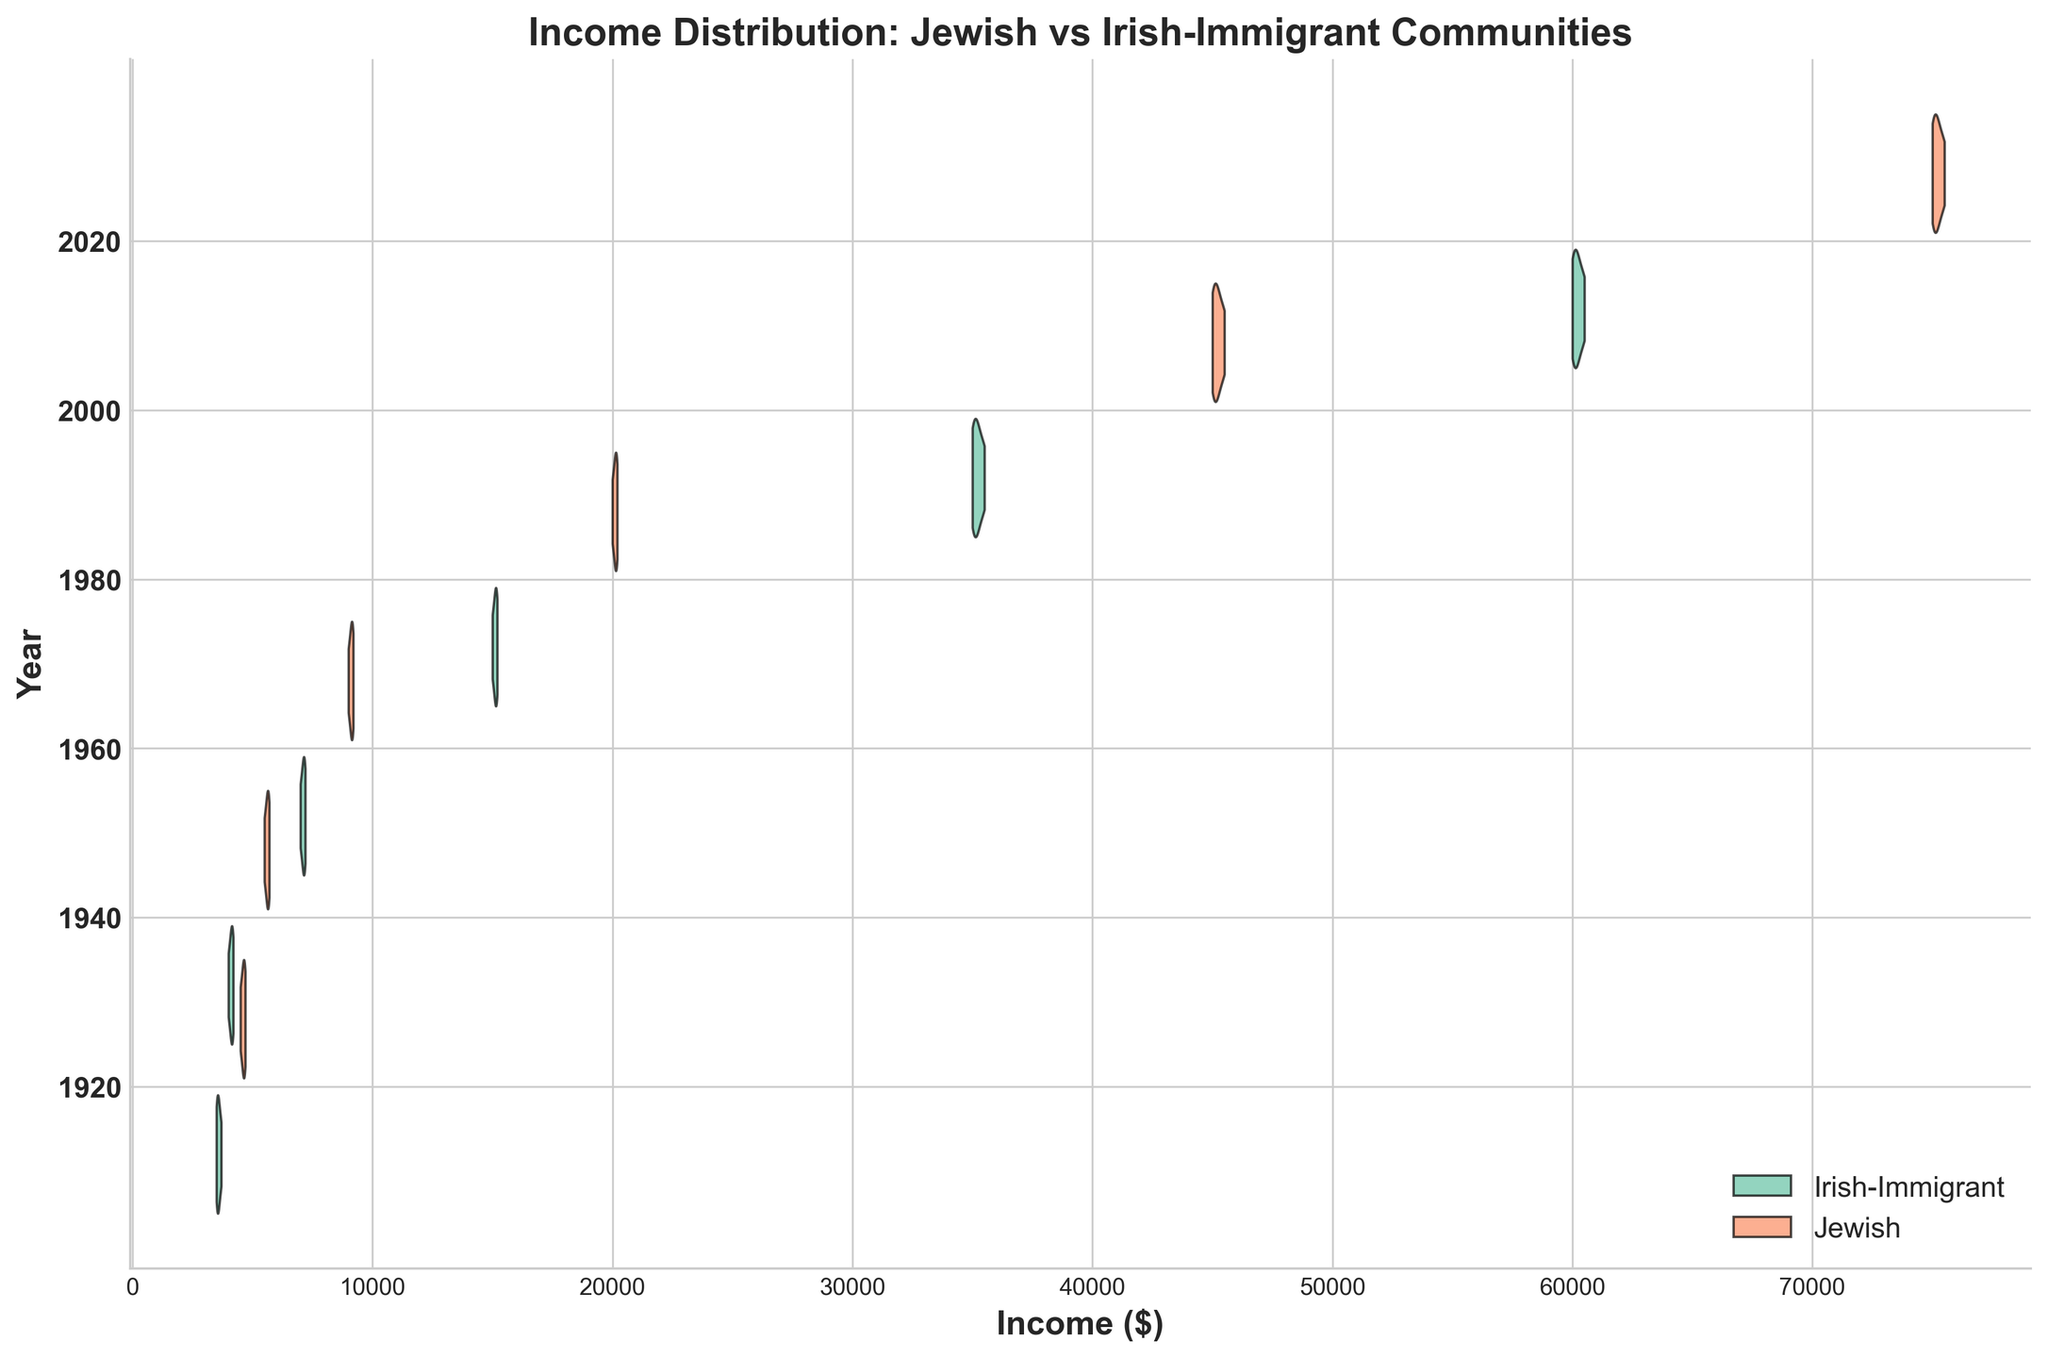What is the title of the figure? The title is located at the top of the figure. It provides a summary of the data being represented.
Answer: Income Distribution: Jewish vs Irish-Immigrant Communities What do the y-axis labels signify? The y-axis labels correspond to different years, indicating the time periods for which the income distributions are shown.
Answer: Years How are the two communities distinguished in the chart? The two communities are distinguished by different colors as indicated in the legend at the lower right of the chart.
Answer: By different colors Which community had a higher income distribution in 1940? By comparing the positions of the violin plots for 1940, the Jewish community's plot is centered around higher income values compared to the Irish-Immigrant community.
Answer: Jewish community How have the median incomes for both communities changed from 1920 to 2020? The median incomes can be estimated from the horizontal center of each violin plot at the respective years. Both communities show an upward trend from 1920 to 2020, with Jewish incomes consistently higher than Irish-Immigrant incomes.
Answer: Increased for both communities What can you deduce about the spread of income distribution for both communities in 1960? The width of the violin plots in 1960 indicates the spread of income distribution. A wider plot suggests a greater spread. Both communities have relatively similar distribution widths, indicating similar income variability.
Answer: Similar spread How do the income distributions in 1980 for the Jewish and Irish-Immigrant communities compare to each other? Comparing the violin plots for 1980, the Jewish community's distribution is centered at a higher income range with slight overlap but overall higher values than the Irish-Immigrant community.
Answer: Jewish community higher Are there any years where the income distributions of the two communities overlap significantly? By observing the overlap of the violin plots, in earlier years like 1920 and 1940, there is more overlap. As time progresses, Jewish incomes increasingly surpass Irish-Immigrant incomes.
Answer: 1920 and 1940 What does the size of the violin plot indicate about the income distribution for each community? The size and shape of the violin plots reflect the density and spread of the income distributions. Narrow plots indicate less variability and wider plots indicate more variability in incomes.
Answer: Density and spread of income distribution 